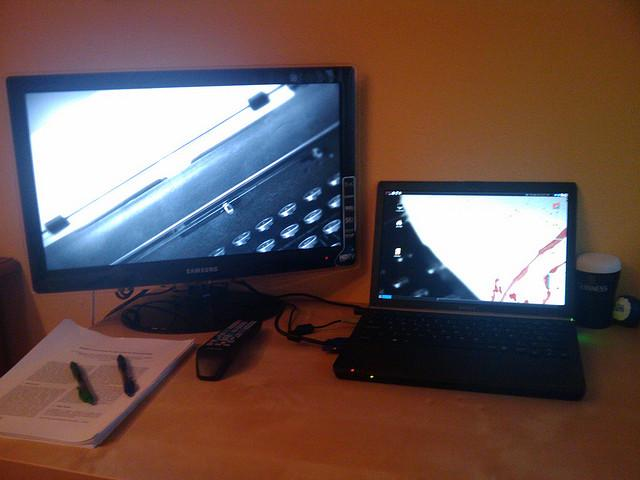By which technology standard is the monitor connected to the laptop? Please explain your reasoning. vga. The vga is connected. 